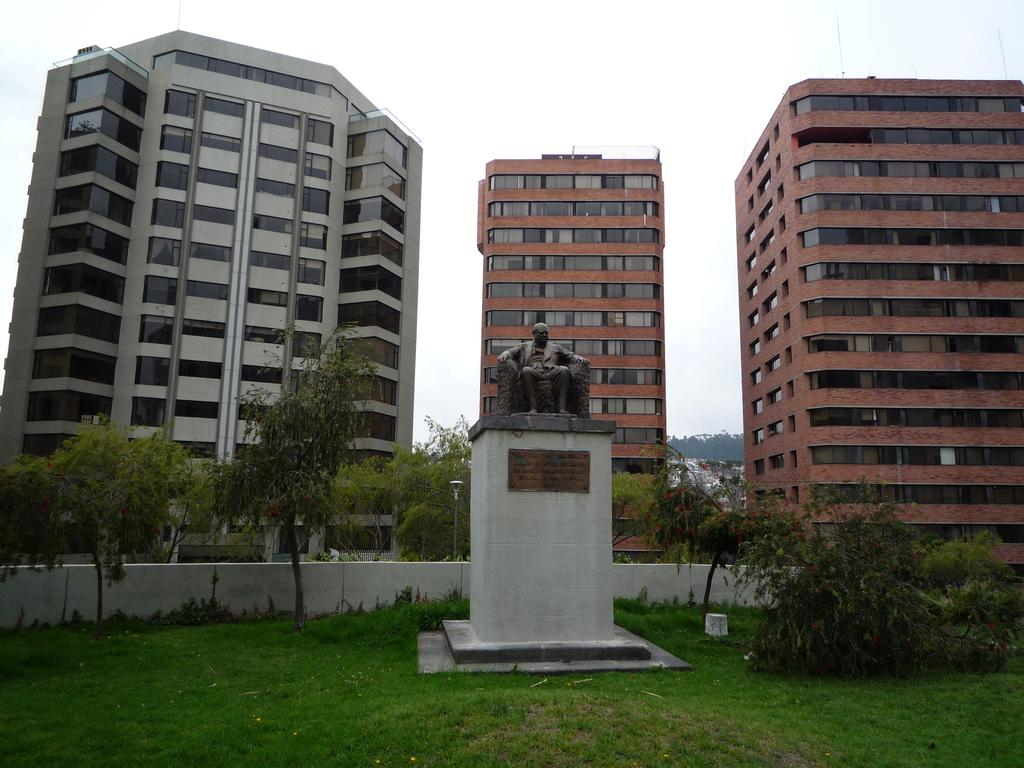What is the main subject in the image? There is a statue in the image. What type of natural environment is visible in the image? There are trees and grass in the image. What type of man-made structures can be seen in the image? There are buildings and a wall in the image. What is visible in the background of the image? The sky is visible in the background of the image. How many bikes are parked next to the statue in the image? There are no bikes present in the image. What type of art is displayed on the wall in the image? There is no art displayed on the wall in the image. What type of cloud can be seen in the sky in the image? There is no cloud visible in the sky in the image. 